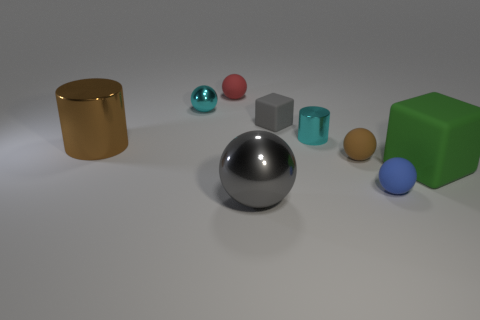Subtract all brown rubber balls. How many balls are left? 4 Subtract all blue spheres. How many spheres are left? 4 Subtract 1 balls. How many balls are left? 4 Subtract all cylinders. How many objects are left? 7 Add 1 cyan metal objects. How many objects exist? 10 Subtract 0 gray cylinders. How many objects are left? 9 Subtract all gray cylinders. Subtract all blue blocks. How many cylinders are left? 2 Subtract all green balls. How many yellow cylinders are left? 0 Subtract all large blue rubber spheres. Subtract all cyan cylinders. How many objects are left? 8 Add 5 red matte objects. How many red matte objects are left? 6 